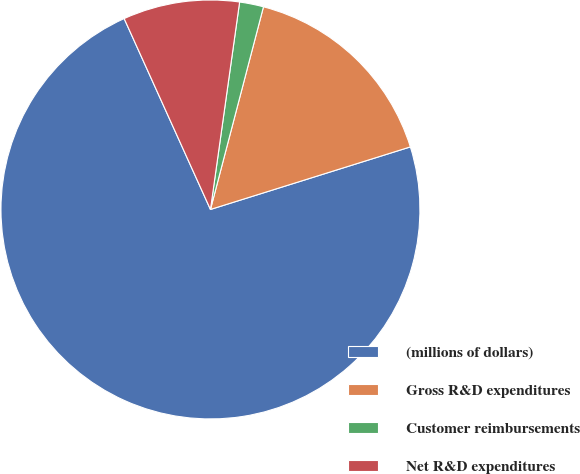Convert chart. <chart><loc_0><loc_0><loc_500><loc_500><pie_chart><fcel>(millions of dollars)<fcel>Gross R&D expenditures<fcel>Customer reimbursements<fcel>Net R&D expenditures<nl><fcel>73.07%<fcel>16.1%<fcel>1.85%<fcel>8.98%<nl></chart> 